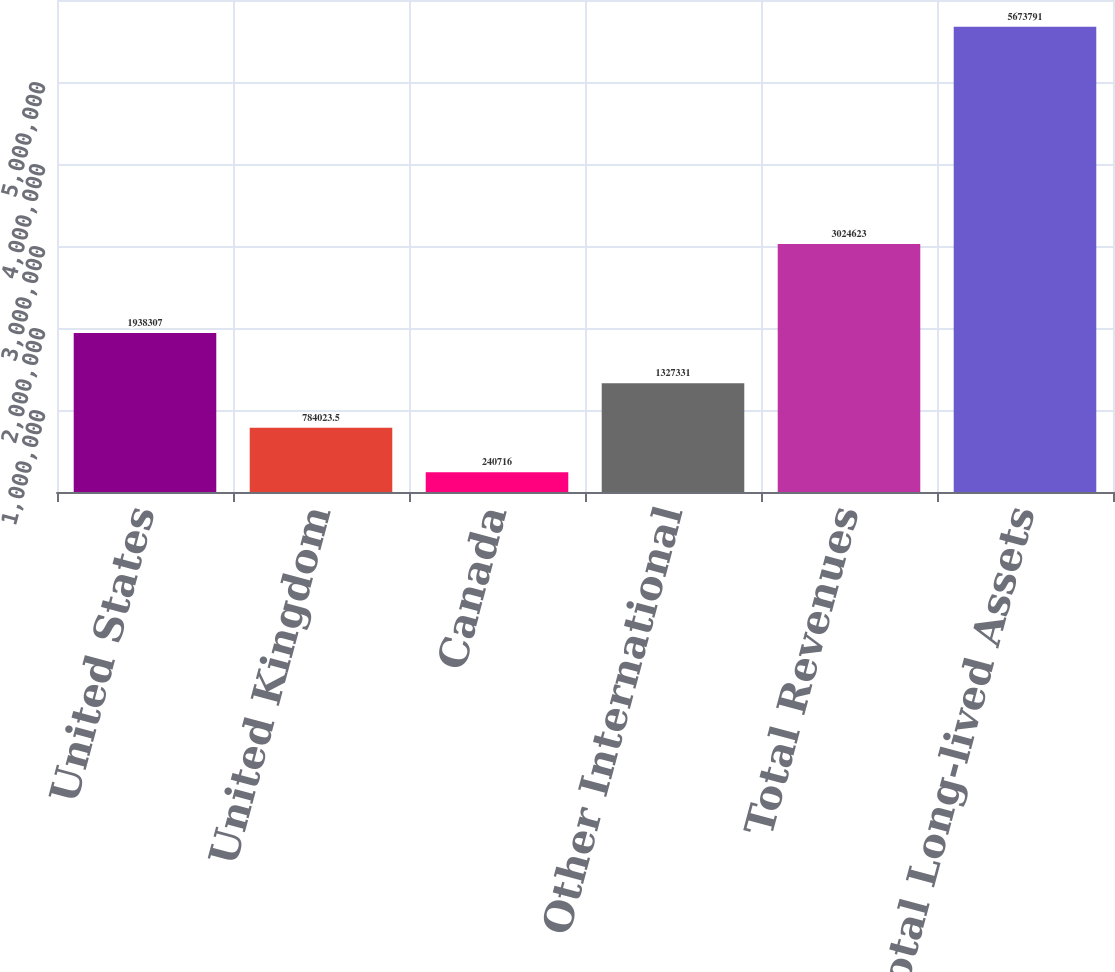<chart> <loc_0><loc_0><loc_500><loc_500><bar_chart><fcel>United States<fcel>United Kingdom<fcel>Canada<fcel>Other International<fcel>Total Revenues<fcel>Total Long-lived Assets<nl><fcel>1.93831e+06<fcel>784024<fcel>240716<fcel>1.32733e+06<fcel>3.02462e+06<fcel>5.67379e+06<nl></chart> 